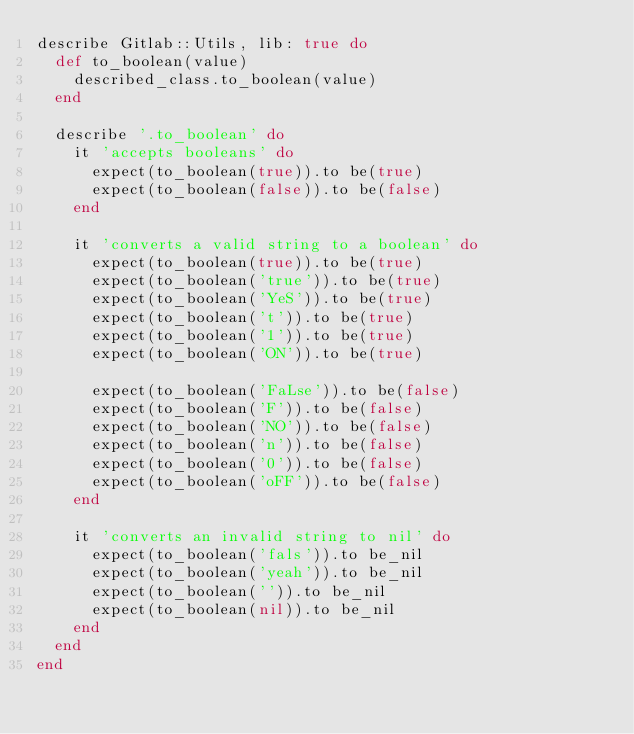Convert code to text. <code><loc_0><loc_0><loc_500><loc_500><_Ruby_>describe Gitlab::Utils, lib: true do
  def to_boolean(value)
    described_class.to_boolean(value)
  end

  describe '.to_boolean' do
    it 'accepts booleans' do
      expect(to_boolean(true)).to be(true)
      expect(to_boolean(false)).to be(false)
    end

    it 'converts a valid string to a boolean' do
      expect(to_boolean(true)).to be(true)
      expect(to_boolean('true')).to be(true)
      expect(to_boolean('YeS')).to be(true)
      expect(to_boolean('t')).to be(true)
      expect(to_boolean('1')).to be(true)
      expect(to_boolean('ON')).to be(true)

      expect(to_boolean('FaLse')).to be(false)
      expect(to_boolean('F')).to be(false)
      expect(to_boolean('NO')).to be(false)
      expect(to_boolean('n')).to be(false)
      expect(to_boolean('0')).to be(false)
      expect(to_boolean('oFF')).to be(false)
    end

    it 'converts an invalid string to nil' do
      expect(to_boolean('fals')).to be_nil
      expect(to_boolean('yeah')).to be_nil
      expect(to_boolean('')).to be_nil
      expect(to_boolean(nil)).to be_nil
    end
  end
end
</code> 